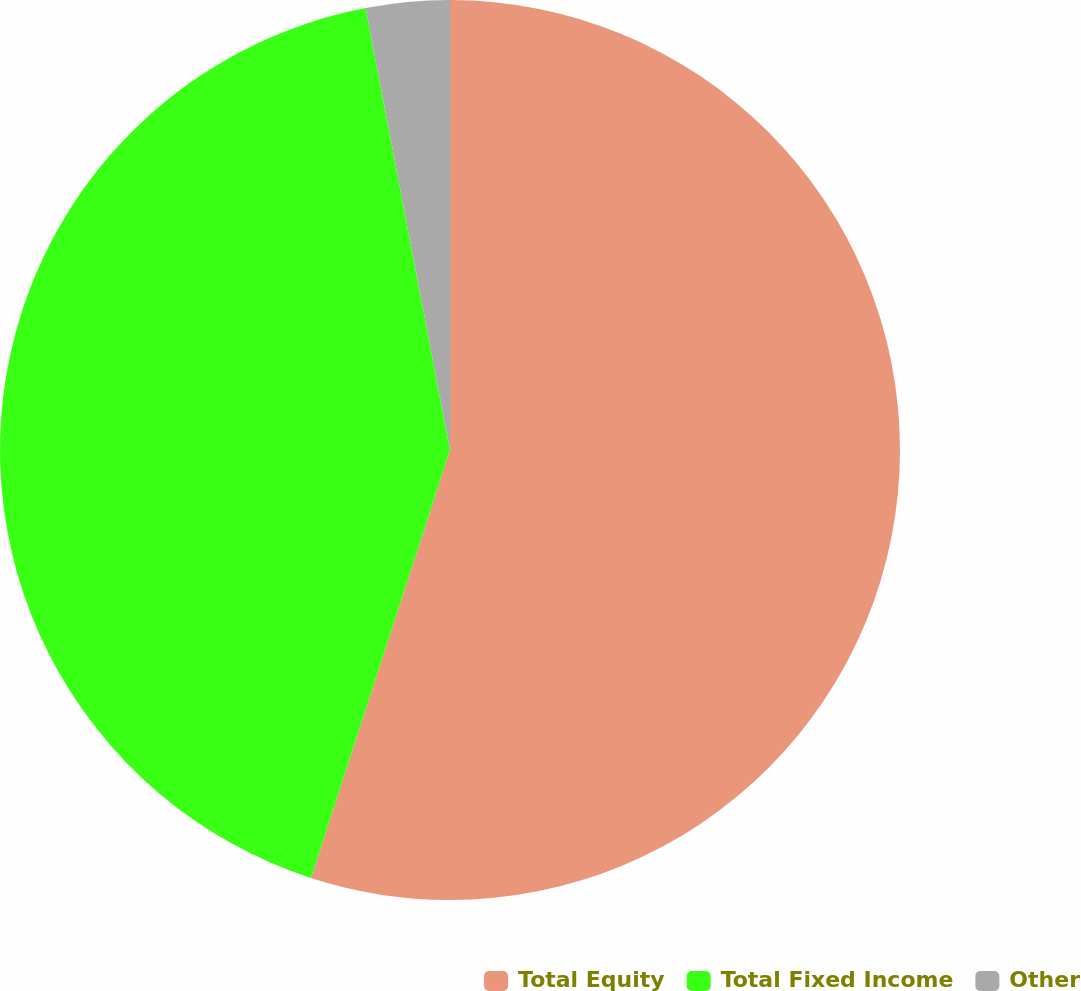Convert chart. <chart><loc_0><loc_0><loc_500><loc_500><pie_chart><fcel>Total Equity<fcel>Total Fixed Income<fcel>Other<nl><fcel>55.0%<fcel>42.0%<fcel>3.0%<nl></chart> 